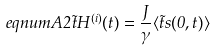<formula> <loc_0><loc_0><loc_500><loc_500>\ e q n u m { A 2 } \vec { t } H ^ { ( i ) } ( t ) = \frac { J } { \gamma } \langle \vec { t } s ( 0 , t ) \rangle</formula> 